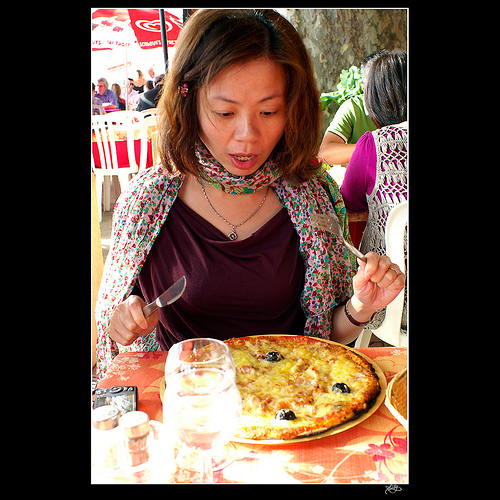<image>
Can you confirm if the pizza is on the table? Yes. Looking at the image, I can see the pizza is positioned on top of the table, with the table providing support. Where is the food in relation to the cup? Is it on the cup? No. The food is not positioned on the cup. They may be near each other, but the food is not supported by or resting on top of the cup. 